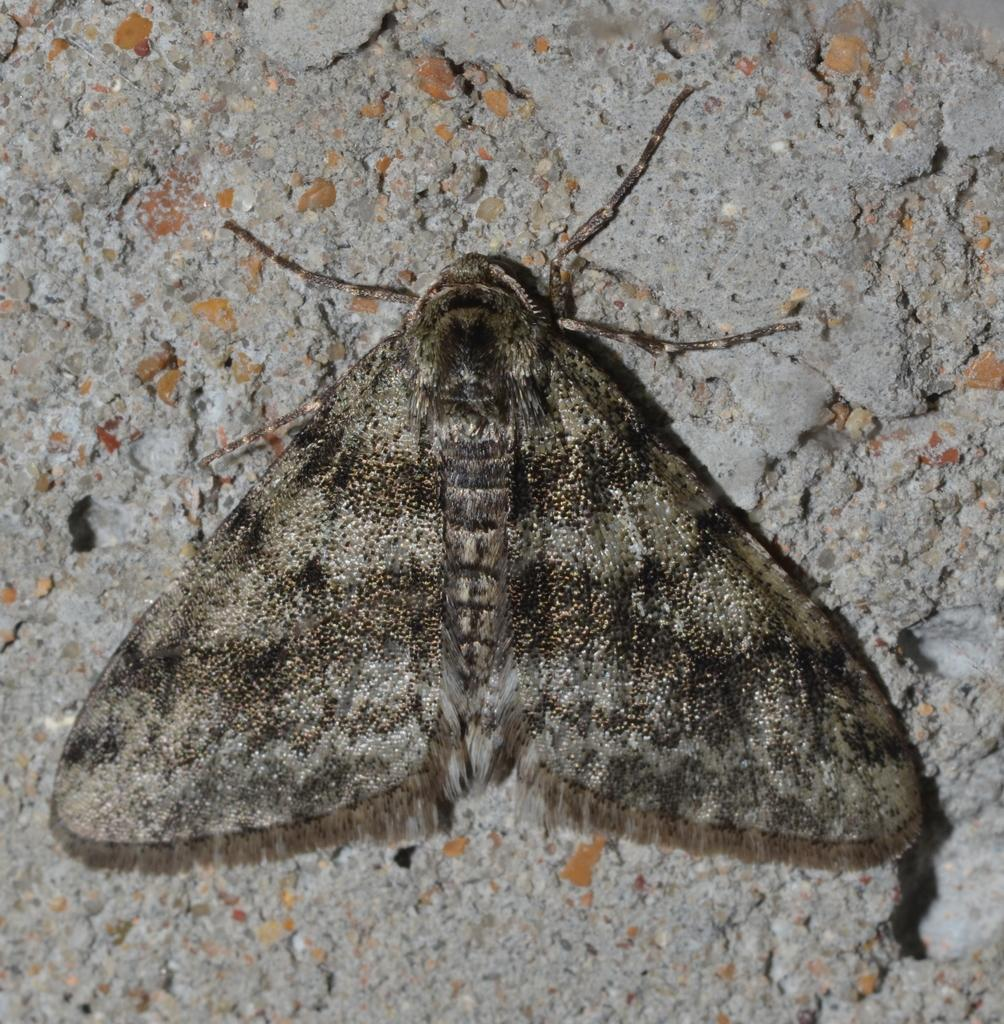What type of creature is in the image? There is an insect in the image. Where is the insect located? The insect is on a surface. Can you describe the surface the insect is on? The surface appears to be a cement base. Who is the owner of the insect in the image? There is no indication of an owner for the insect in the image. Can you tell me what type of hat the insect is wearing in the image? There is no hat present on the insect in the image. 